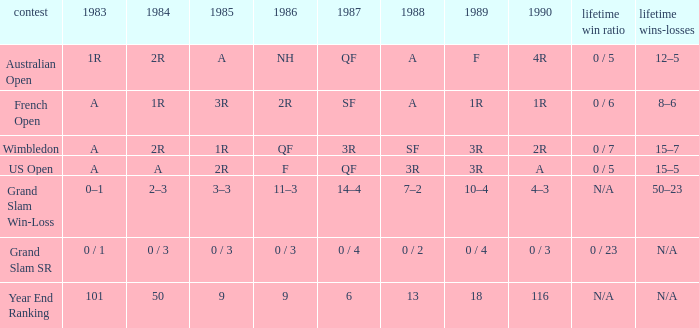What is the 1987 results when the results of 1989 is 3R, and the 1986 results is F? QF. Would you mind parsing the complete table? {'header': ['contest', '1983', '1984', '1985', '1986', '1987', '1988', '1989', '1990', 'lifetime win ratio', 'lifetime wins-losses'], 'rows': [['Australian Open', '1R', '2R', 'A', 'NH', 'QF', 'A', 'F', '4R', '0 / 5', '12–5'], ['French Open', 'A', '1R', '3R', '2R', 'SF', 'A', '1R', '1R', '0 / 6', '8–6'], ['Wimbledon', 'A', '2R', '1R', 'QF', '3R', 'SF', '3R', '2R', '0 / 7', '15–7'], ['US Open', 'A', 'A', '2R', 'F', 'QF', '3R', '3R', 'A', '0 / 5', '15–5'], ['Grand Slam Win-Loss', '0–1', '2–3', '3–3', '11–3', '14–4', '7–2', '10–4', '4–3', 'N/A', '50–23'], ['Grand Slam SR', '0 / 1', '0 / 3', '0 / 3', '0 / 3', '0 / 4', '0 / 2', '0 / 4', '0 / 3', '0 / 23', 'N/A'], ['Year End Ranking', '101', '50', '9', '9', '6', '13', '18', '116', 'N/A', 'N/A']]} 